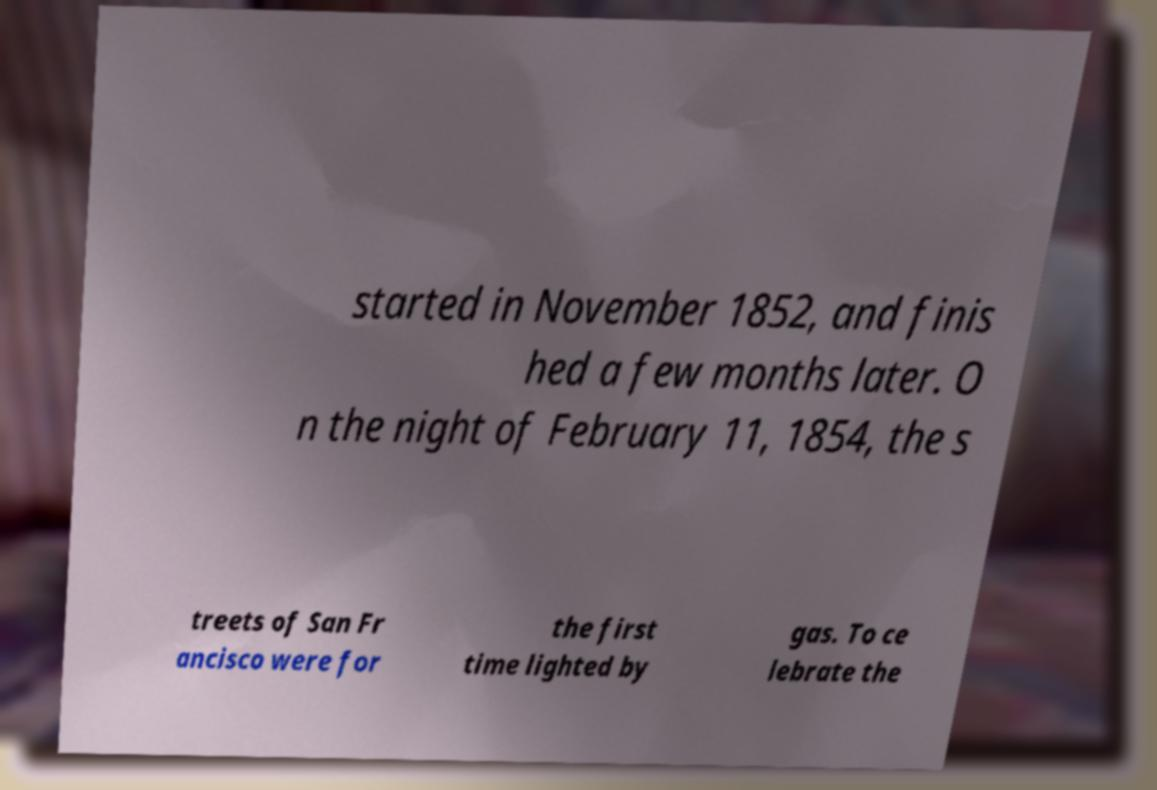There's text embedded in this image that I need extracted. Can you transcribe it verbatim? started in November 1852, and finis hed a few months later. O n the night of February 11, 1854, the s treets of San Fr ancisco were for the first time lighted by gas. To ce lebrate the 